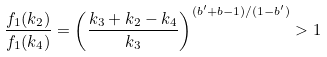<formula> <loc_0><loc_0><loc_500><loc_500>\frac { f _ { 1 } ( k _ { 2 } ) } { f _ { 1 } ( k _ { 4 } ) } = \left ( \frac { k _ { 3 } + k _ { 2 } - k _ { 4 } } { k _ { 3 } } \right ) ^ { ( b ^ { \prime } + b - 1 ) / ( 1 - b ^ { \prime } ) } > 1</formula> 